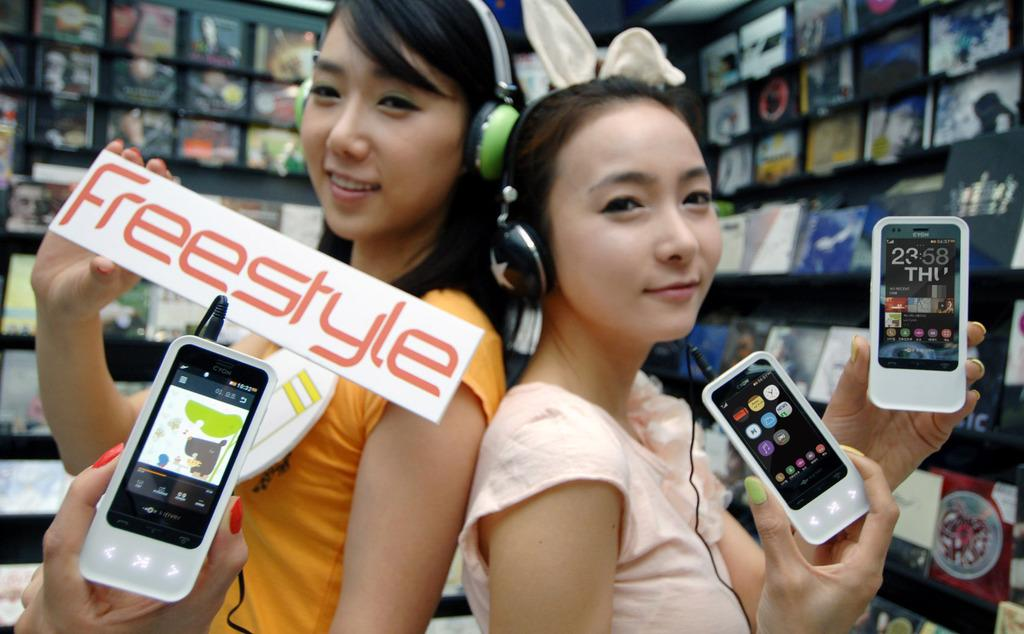How many people are in the image? There are two girls in the image. What are the girls doing in the image? The girls are standing and holding mobile phones. What can be seen in the background of the image? There are books in the background of the image. Where are the books located in the image? The books are kept on a wall. How many cats are visible in the image? There are no cats present in the image. Is there a kite being flown by the girls in the image? There is no kite visible in the image. 